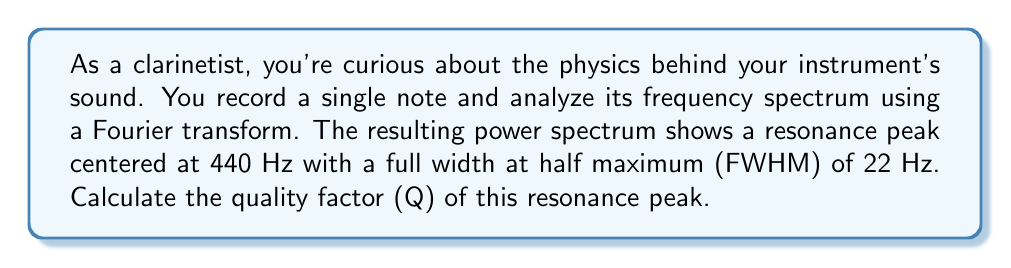Show me your answer to this math problem. To solve this problem, we'll follow these steps:

1) The quality factor (Q) is related to the bandwidth of a resonance peak. It's defined as:

   $$ Q = \frac{f_0}{\Delta f} $$

   Where $f_0$ is the center frequency and $\Delta f$ is the bandwidth.

2) In this case, $f_0 = 440$ Hz (the center of the peak).

3) The bandwidth $\Delta f$ is given by the full width at half maximum (FWHM), which is 22 Hz.

4) We can now substitute these values into the equation:

   $$ Q = \frac{440 \text{ Hz}}{22 \text{ Hz}} $$

5) Performing the division:

   $$ Q = 20 $$

The quality factor is a dimensionless quantity, so no units are needed in the final answer.
Answer: 20 